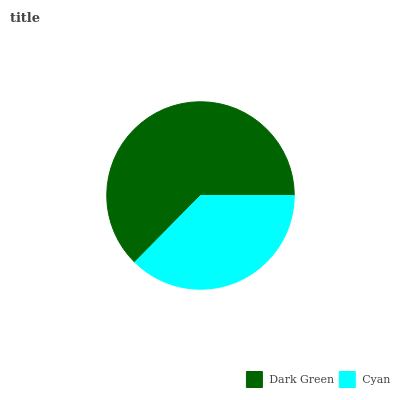Is Cyan the minimum?
Answer yes or no. Yes. Is Dark Green the maximum?
Answer yes or no. Yes. Is Cyan the maximum?
Answer yes or no. No. Is Dark Green greater than Cyan?
Answer yes or no. Yes. Is Cyan less than Dark Green?
Answer yes or no. Yes. Is Cyan greater than Dark Green?
Answer yes or no. No. Is Dark Green less than Cyan?
Answer yes or no. No. Is Dark Green the high median?
Answer yes or no. Yes. Is Cyan the low median?
Answer yes or no. Yes. Is Cyan the high median?
Answer yes or no. No. Is Dark Green the low median?
Answer yes or no. No. 